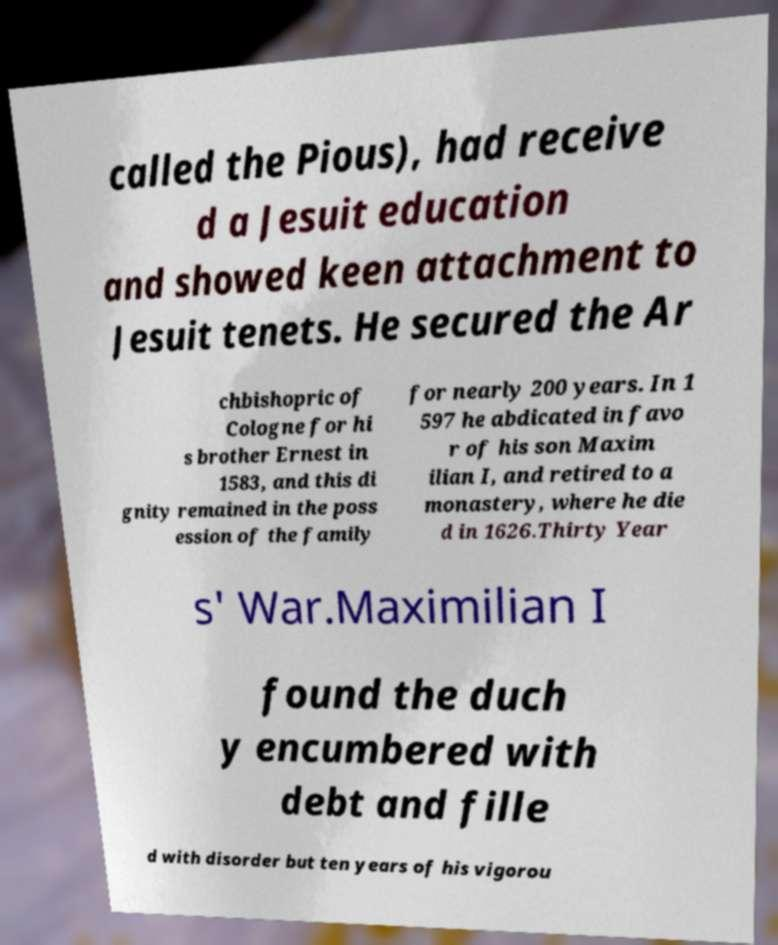Can you read and provide the text displayed in the image?This photo seems to have some interesting text. Can you extract and type it out for me? called the Pious), had receive d a Jesuit education and showed keen attachment to Jesuit tenets. He secured the Ar chbishopric of Cologne for hi s brother Ernest in 1583, and this di gnity remained in the poss ession of the family for nearly 200 years. In 1 597 he abdicated in favo r of his son Maxim ilian I, and retired to a monastery, where he die d in 1626.Thirty Year s' War.Maximilian I found the duch y encumbered with debt and fille d with disorder but ten years of his vigorou 